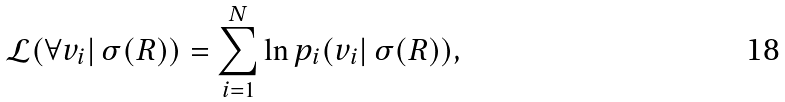Convert formula to latex. <formula><loc_0><loc_0><loc_500><loc_500>\mathcal { L } ( \forall v _ { i } | \, \sigma ( R ) ) = \sum _ { i = 1 } ^ { N } \ln p _ { i } ( v _ { i } | \, \sigma ( R ) ) ,</formula> 